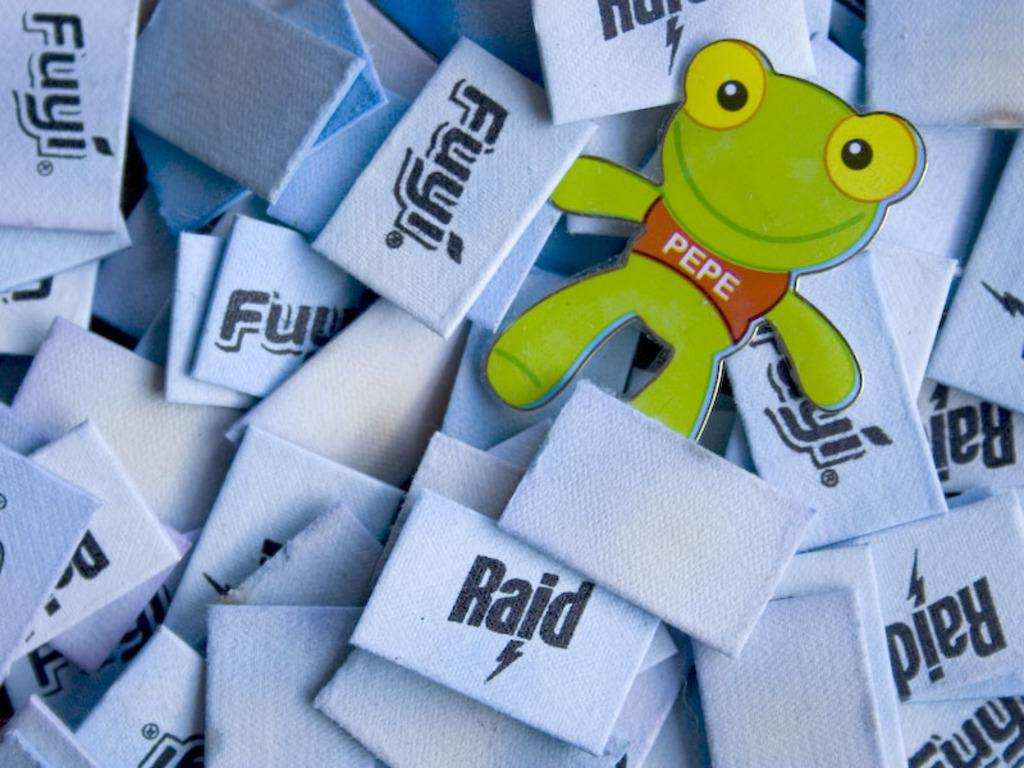What can be seen in the image that has text or writing on it? There are labels in the image. What type of visual element is present in the image that is not text-based? There is a cartoon image in the image. What type of pie is being served on the table in the image? There is no table or pie present in the image; it only features labels and a cartoon image. What is the current status of the electricity in the image? There is no reference to electricity or its status in the image. 